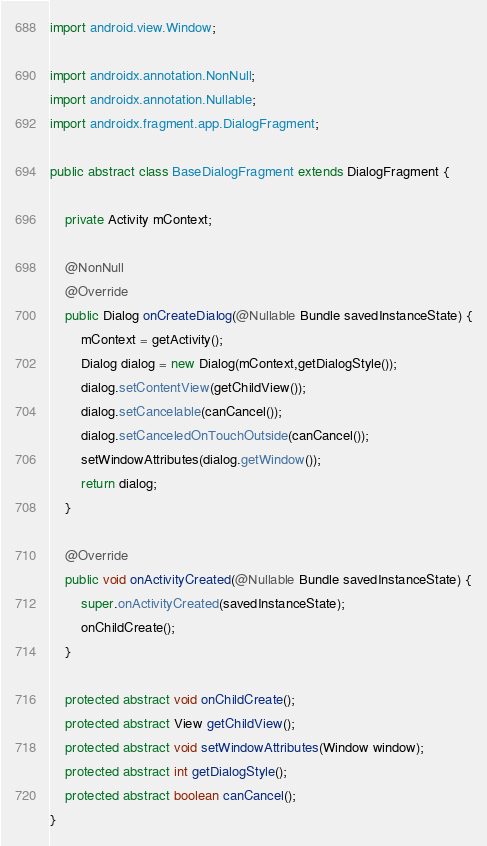Convert code to text. <code><loc_0><loc_0><loc_500><loc_500><_Java_>import android.view.Window;

import androidx.annotation.NonNull;
import androidx.annotation.Nullable;
import androidx.fragment.app.DialogFragment;

public abstract class BaseDialogFragment extends DialogFragment {

    private Activity mContext;

    @NonNull
    @Override
    public Dialog onCreateDialog(@Nullable Bundle savedInstanceState) {
        mContext = getActivity();
        Dialog dialog = new Dialog(mContext,getDialogStyle());
        dialog.setContentView(getChildView());
        dialog.setCancelable(canCancel());
        dialog.setCanceledOnTouchOutside(canCancel());
        setWindowAttributes(dialog.getWindow());
        return dialog;
    }

    @Override
    public void onActivityCreated(@Nullable Bundle savedInstanceState) {
        super.onActivityCreated(savedInstanceState);
        onChildCreate();
    }

    protected abstract void onChildCreate();
    protected abstract View getChildView();
    protected abstract void setWindowAttributes(Window window);
    protected abstract int getDialogStyle();
    protected abstract boolean canCancel();
}
</code> 